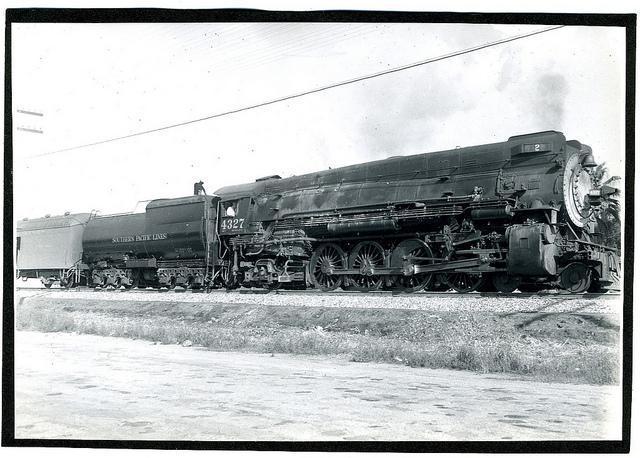How many train cars have yellow on them?
Give a very brief answer. 0. 